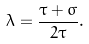<formula> <loc_0><loc_0><loc_500><loc_500>\lambda = \frac { \tau + \sigma } { 2 \tau } .</formula> 